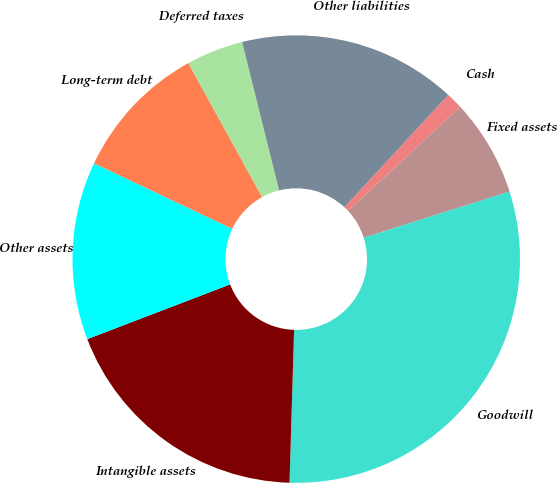<chart> <loc_0><loc_0><loc_500><loc_500><pie_chart><fcel>Cash<fcel>Fixed assets<fcel>Goodwill<fcel>Intangible assets<fcel>Other assets<fcel>Long-term debt<fcel>Deferred taxes<fcel>Other liabilities<nl><fcel>1.2%<fcel>7.03%<fcel>30.36%<fcel>18.7%<fcel>12.86%<fcel>9.95%<fcel>4.12%<fcel>15.78%<nl></chart> 